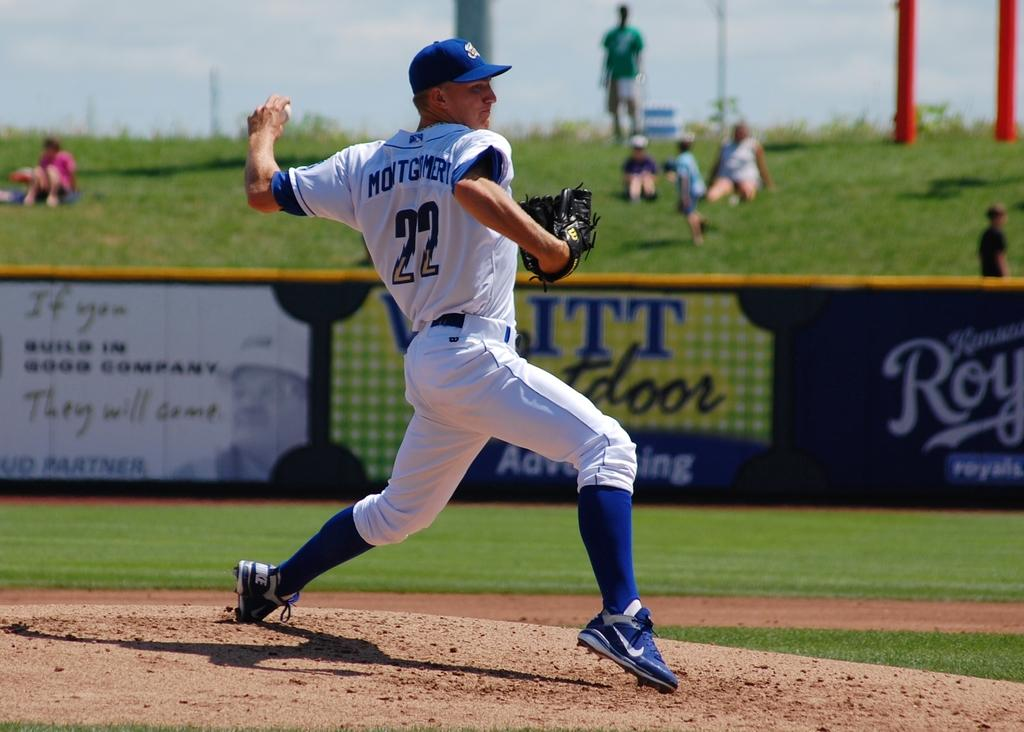<image>
Write a terse but informative summary of the picture. a player with the number 22 pitching a ball 